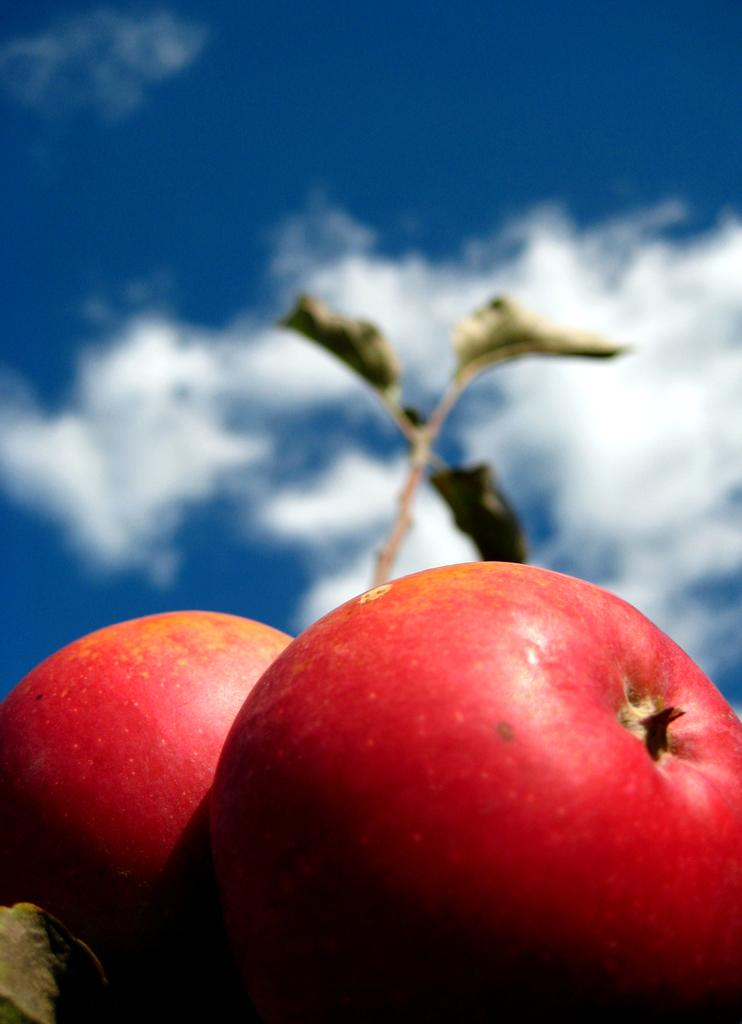What objects are in the foreground of the image? There are two apples in the foreground of the image. What can be seen in the background of the image? There are leaves and the sky visible in the background of the image. What type of books can be seen in the image? There are no books or library depicted in the image; it features two apples in the foreground and leaves and sky in the background. 